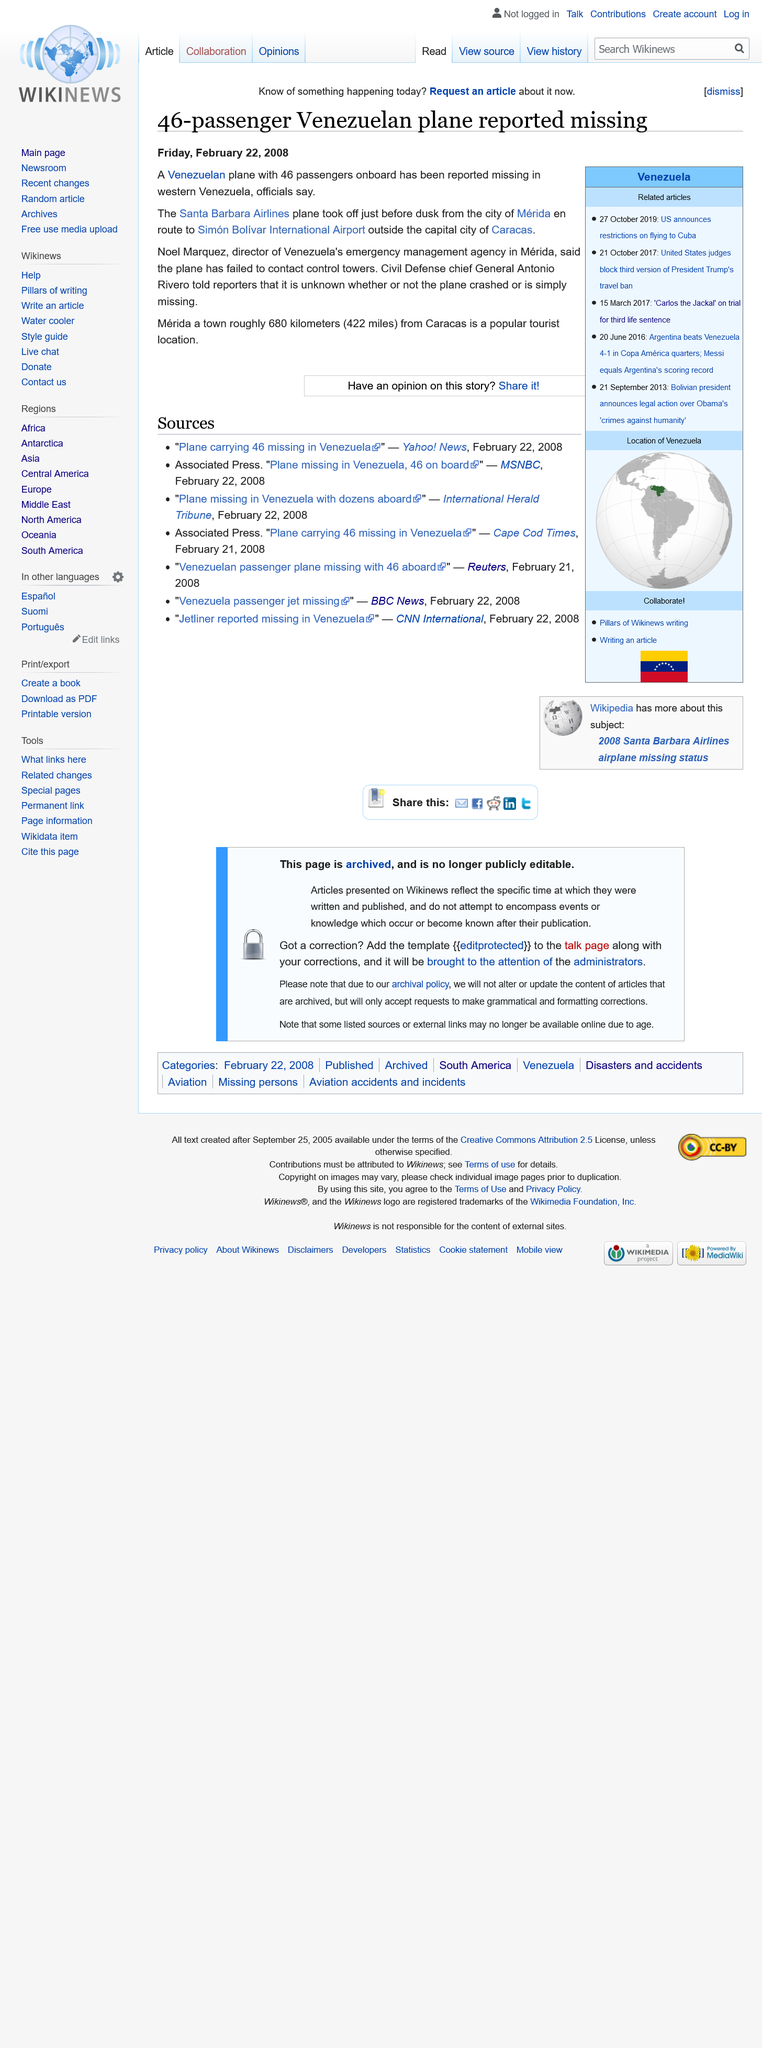List a handful of essential elements in this visual. The plane failed to make contact with the control tower, indicating a failure in communication and control during flight. The plane that went missing had 46 passengers onboard. The article on the Venezuelan plane that disappeared was published on Friday, February 22, 2008. 